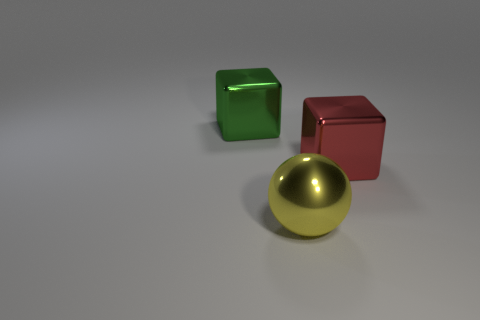Add 3 red metal things. How many objects exist? 6 Subtract all blocks. How many objects are left? 1 Add 3 yellow metal objects. How many yellow metal objects are left? 4 Add 3 gray metal cubes. How many gray metal cubes exist? 3 Subtract 0 yellow cubes. How many objects are left? 3 Subtract all large cyan matte blocks. Subtract all big cubes. How many objects are left? 1 